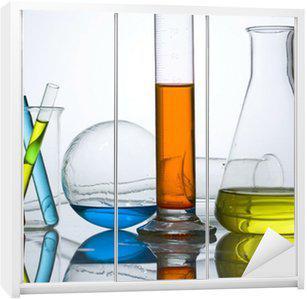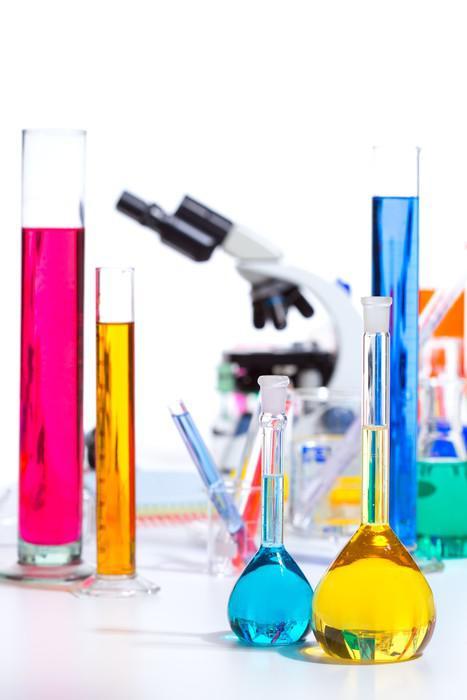The first image is the image on the left, the second image is the image on the right. Evaluate the accuracy of this statement regarding the images: "There are five test tubes in the left image.". Is it true? Answer yes or no. No. 